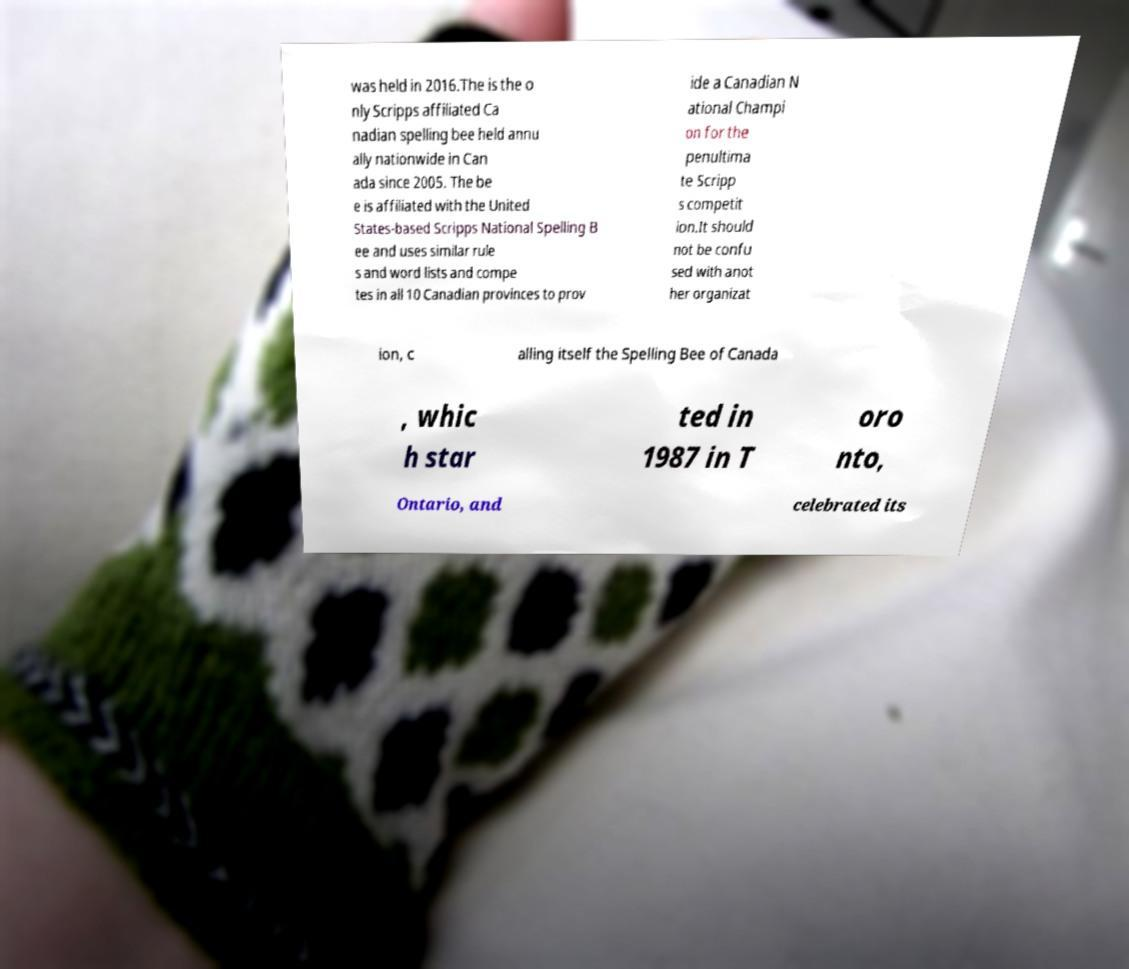Can you read and provide the text displayed in the image?This photo seems to have some interesting text. Can you extract and type it out for me? was held in 2016.The is the o nly Scripps affiliated Ca nadian spelling bee held annu ally nationwide in Can ada since 2005. The be e is affiliated with the United States-based Scripps National Spelling B ee and uses similar rule s and word lists and compe tes in all 10 Canadian provinces to prov ide a Canadian N ational Champi on for the penultima te Scripp s competit ion.It should not be confu sed with anot her organizat ion, c alling itself the Spelling Bee of Canada , whic h star ted in 1987 in T oro nto, Ontario, and celebrated its 